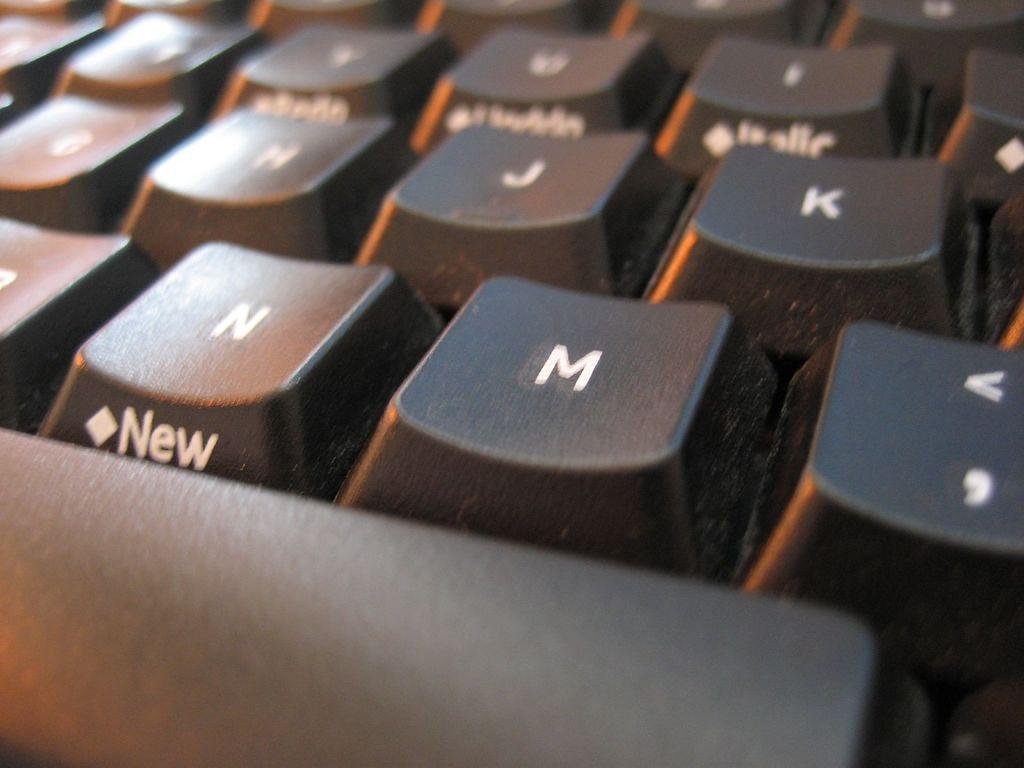<image>
Share a concise interpretation of the image provided. a keyboard with the word 'new' on the side of key 'n' 